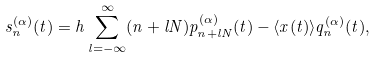<formula> <loc_0><loc_0><loc_500><loc_500>s _ { n } ^ { ( \alpha ) } ( t ) = h \sum _ { l = - \infty } ^ { \infty } ( n + l N ) p _ { n + l N } ^ { ( \alpha ) } ( t ) - \langle x ( t ) \rangle q _ { n } ^ { ( \alpha ) } ( t ) ,</formula> 